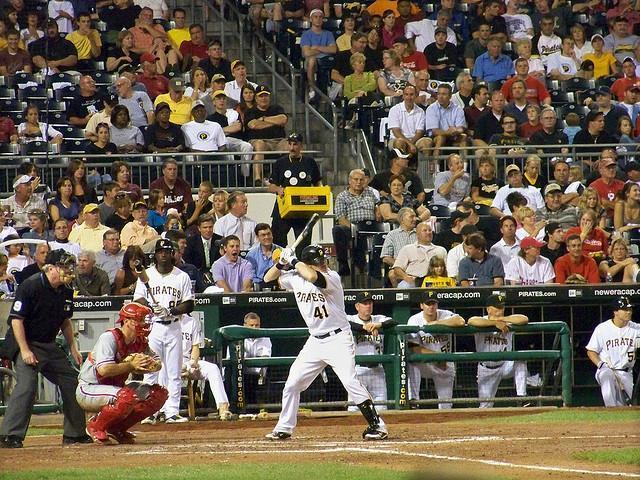How many people are there?
Give a very brief answer. 7. 